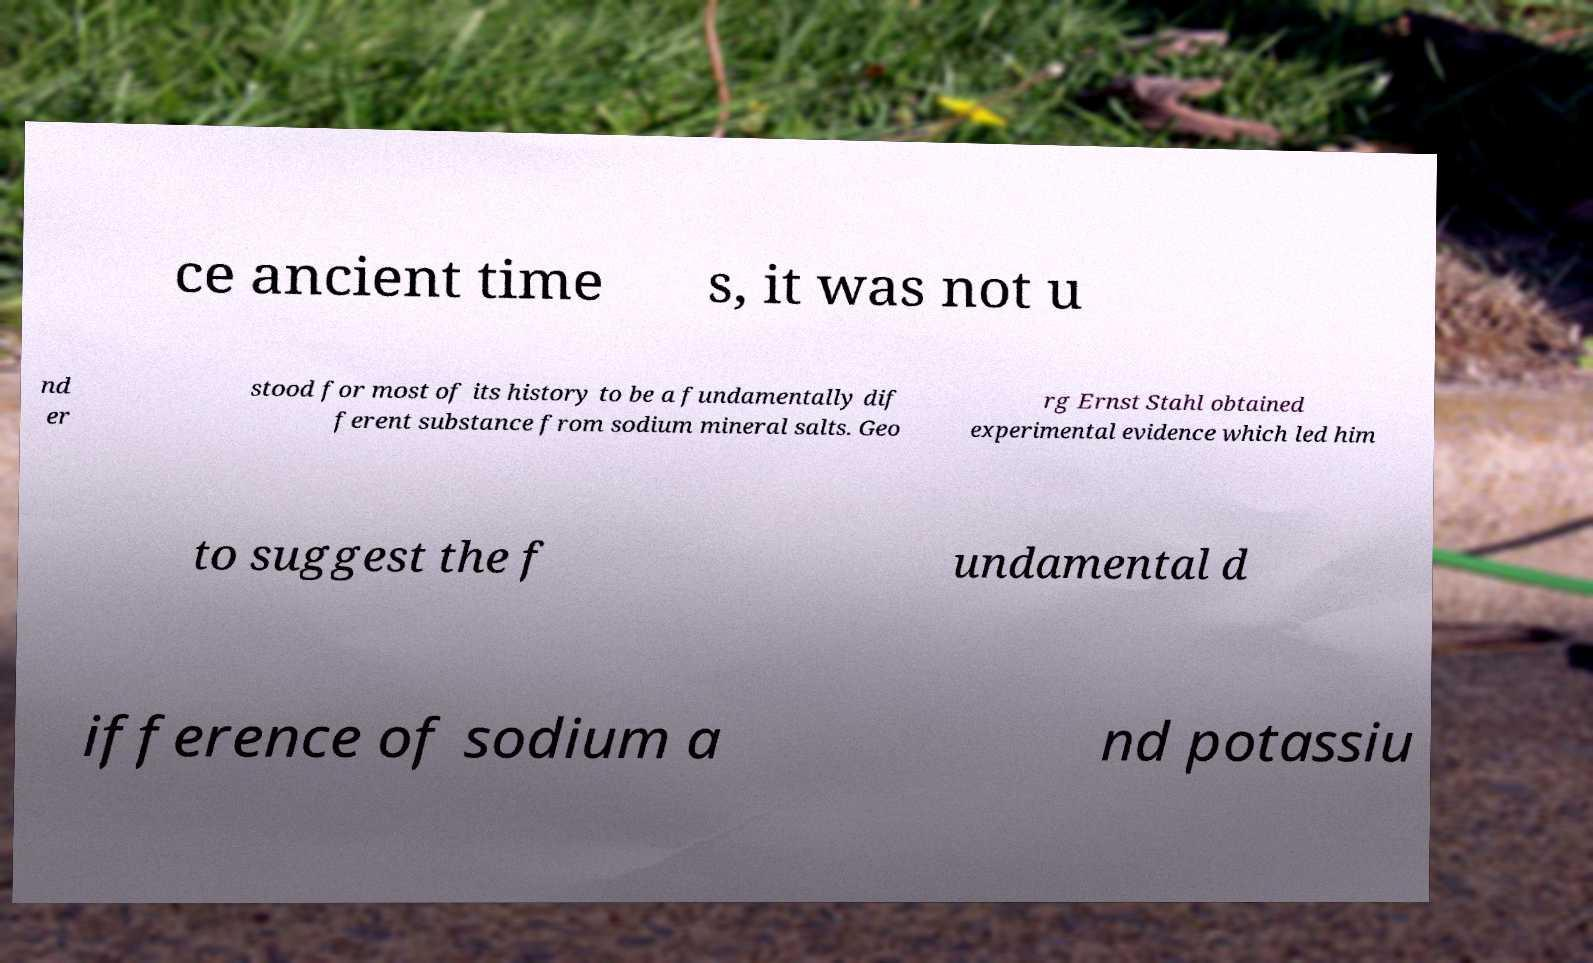For documentation purposes, I need the text within this image transcribed. Could you provide that? ce ancient time s, it was not u nd er stood for most of its history to be a fundamentally dif ferent substance from sodium mineral salts. Geo rg Ernst Stahl obtained experimental evidence which led him to suggest the f undamental d ifference of sodium a nd potassiu 